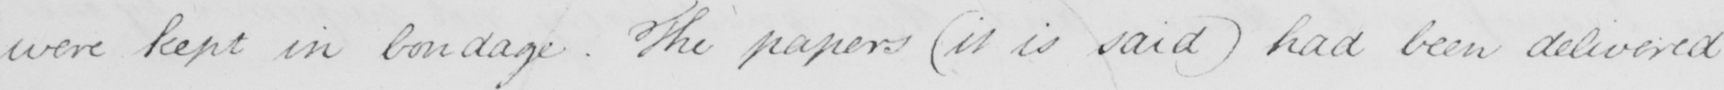Can you read and transcribe this handwriting? were kept in bondage . The papers  ( it is said )  had been delivered 